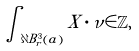Convert formula to latex. <formula><loc_0><loc_0><loc_500><loc_500>\int _ { \partial B _ { r } ^ { 3 } ( a ) } X \cdot \nu \in \mathbb { Z } ,</formula> 